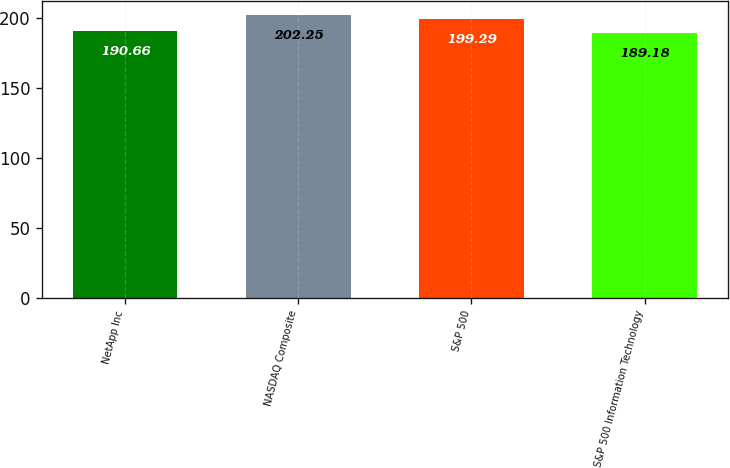Convert chart to OTSL. <chart><loc_0><loc_0><loc_500><loc_500><bar_chart><fcel>NetApp Inc<fcel>NASDAQ Composite<fcel>S&P 500<fcel>S&P 500 Information Technology<nl><fcel>190.66<fcel>202.25<fcel>199.29<fcel>189.18<nl></chart> 